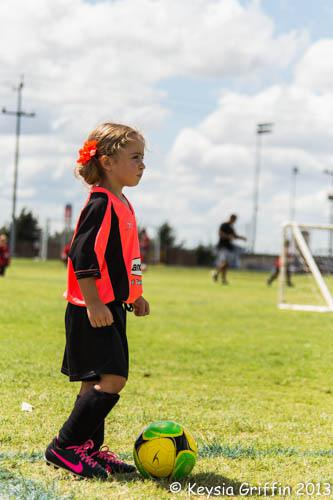Question: what color is the flower?
Choices:
A. Yellow.
B. Red.
C. Orange.
D. Green.
Answer with the letter. Answer: C Question: what sport is being played?
Choices:
A. Football.
B. Rugby.
C. Baseball.
D. Soccer.
Answer with the letter. Answer: D Question: why is it so bright?
Choices:
A. The light is on.
B. It's daytime.
C. Sunny.
D. The window is open.
Answer with the letter. Answer: C Question: who is wearing pink?
Choices:
A. A girl.
B. The woman holding a umbrella.
C. The man on his cellphone.
D. The lady sitting on the bench.
Answer with the letter. Answer: A Question: where was the photo taken?
Choices:
A. At the zoo.
B. At a bar.
C. A field.
D. At a concert.
Answer with the letter. Answer: C 